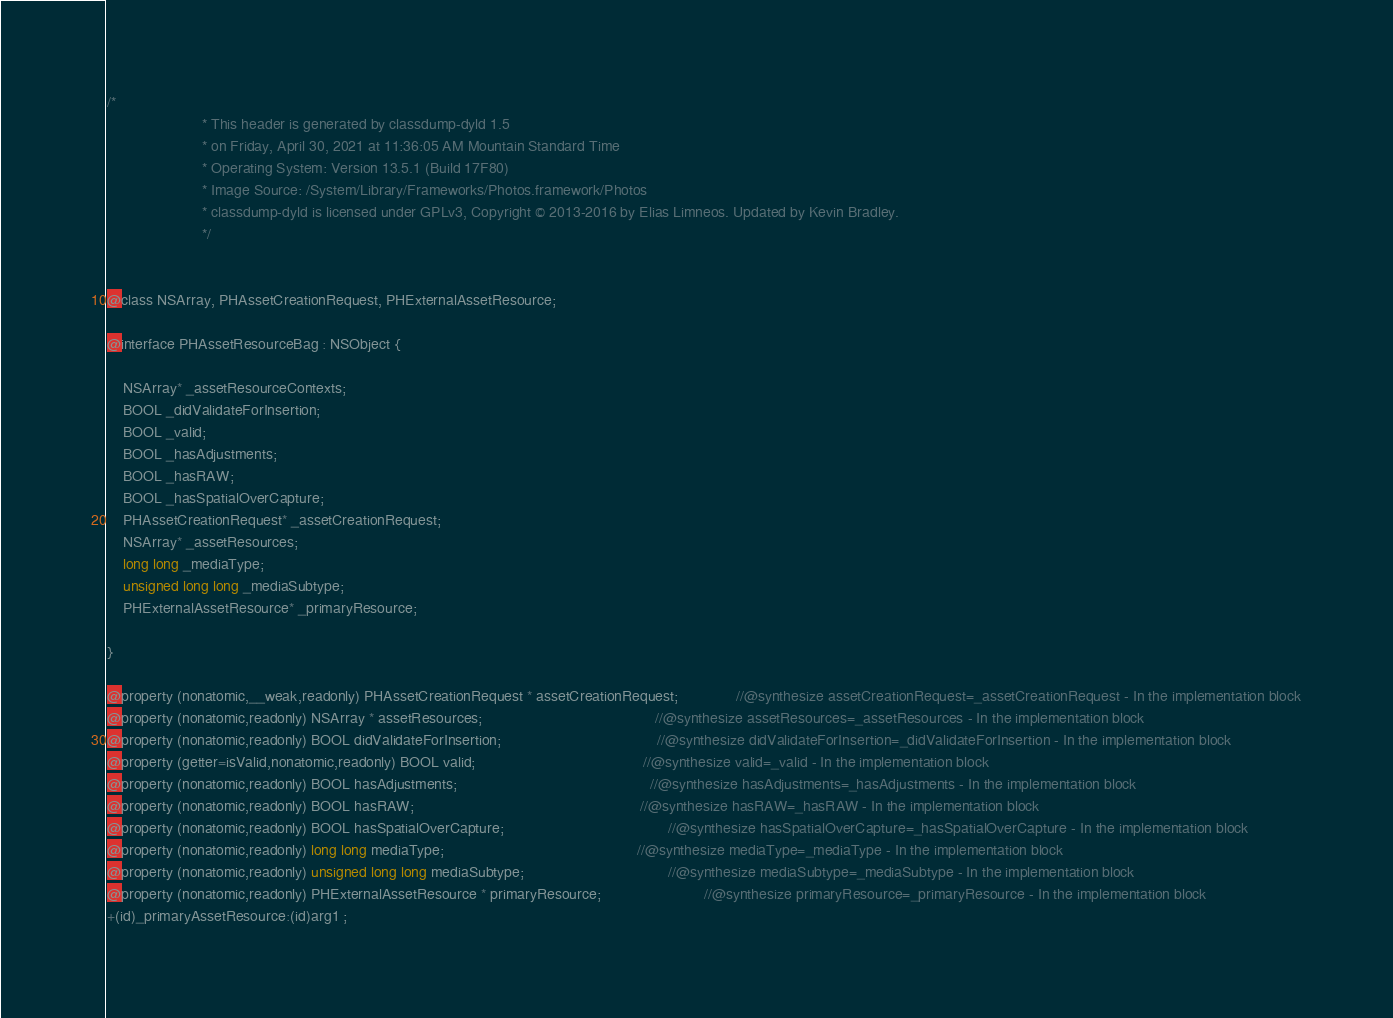Convert code to text. <code><loc_0><loc_0><loc_500><loc_500><_C_>/*
                       * This header is generated by classdump-dyld 1.5
                       * on Friday, April 30, 2021 at 11:36:05 AM Mountain Standard Time
                       * Operating System: Version 13.5.1 (Build 17F80)
                       * Image Source: /System/Library/Frameworks/Photos.framework/Photos
                       * classdump-dyld is licensed under GPLv3, Copyright © 2013-2016 by Elias Limneos. Updated by Kevin Bradley.
                       */


@class NSArray, PHAssetCreationRequest, PHExternalAssetResource;

@interface PHAssetResourceBag : NSObject {

	NSArray* _assetResourceContexts;
	BOOL _didValidateForInsertion;
	BOOL _valid;
	BOOL _hasAdjustments;
	BOOL _hasRAW;
	BOOL _hasSpatialOverCapture;
	PHAssetCreationRequest* _assetCreationRequest;
	NSArray* _assetResources;
	long long _mediaType;
	unsigned long long _mediaSubtype;
	PHExternalAssetResource* _primaryResource;

}

@property (nonatomic,__weak,readonly) PHAssetCreationRequest * assetCreationRequest;              //@synthesize assetCreationRequest=_assetCreationRequest - In the implementation block
@property (nonatomic,readonly) NSArray * assetResources;                                          //@synthesize assetResources=_assetResources - In the implementation block
@property (nonatomic,readonly) BOOL didValidateForInsertion;                                      //@synthesize didValidateForInsertion=_didValidateForInsertion - In the implementation block
@property (getter=isValid,nonatomic,readonly) BOOL valid;                                         //@synthesize valid=_valid - In the implementation block
@property (nonatomic,readonly) BOOL hasAdjustments;                                               //@synthesize hasAdjustments=_hasAdjustments - In the implementation block
@property (nonatomic,readonly) BOOL hasRAW;                                                       //@synthesize hasRAW=_hasRAW - In the implementation block
@property (nonatomic,readonly) BOOL hasSpatialOverCapture;                                        //@synthesize hasSpatialOverCapture=_hasSpatialOverCapture - In the implementation block
@property (nonatomic,readonly) long long mediaType;                                               //@synthesize mediaType=_mediaType - In the implementation block
@property (nonatomic,readonly) unsigned long long mediaSubtype;                                   //@synthesize mediaSubtype=_mediaSubtype - In the implementation block
@property (nonatomic,readonly) PHExternalAssetResource * primaryResource;                         //@synthesize primaryResource=_primaryResource - In the implementation block
+(id)_primaryAssetResource:(id)arg1 ;</code> 